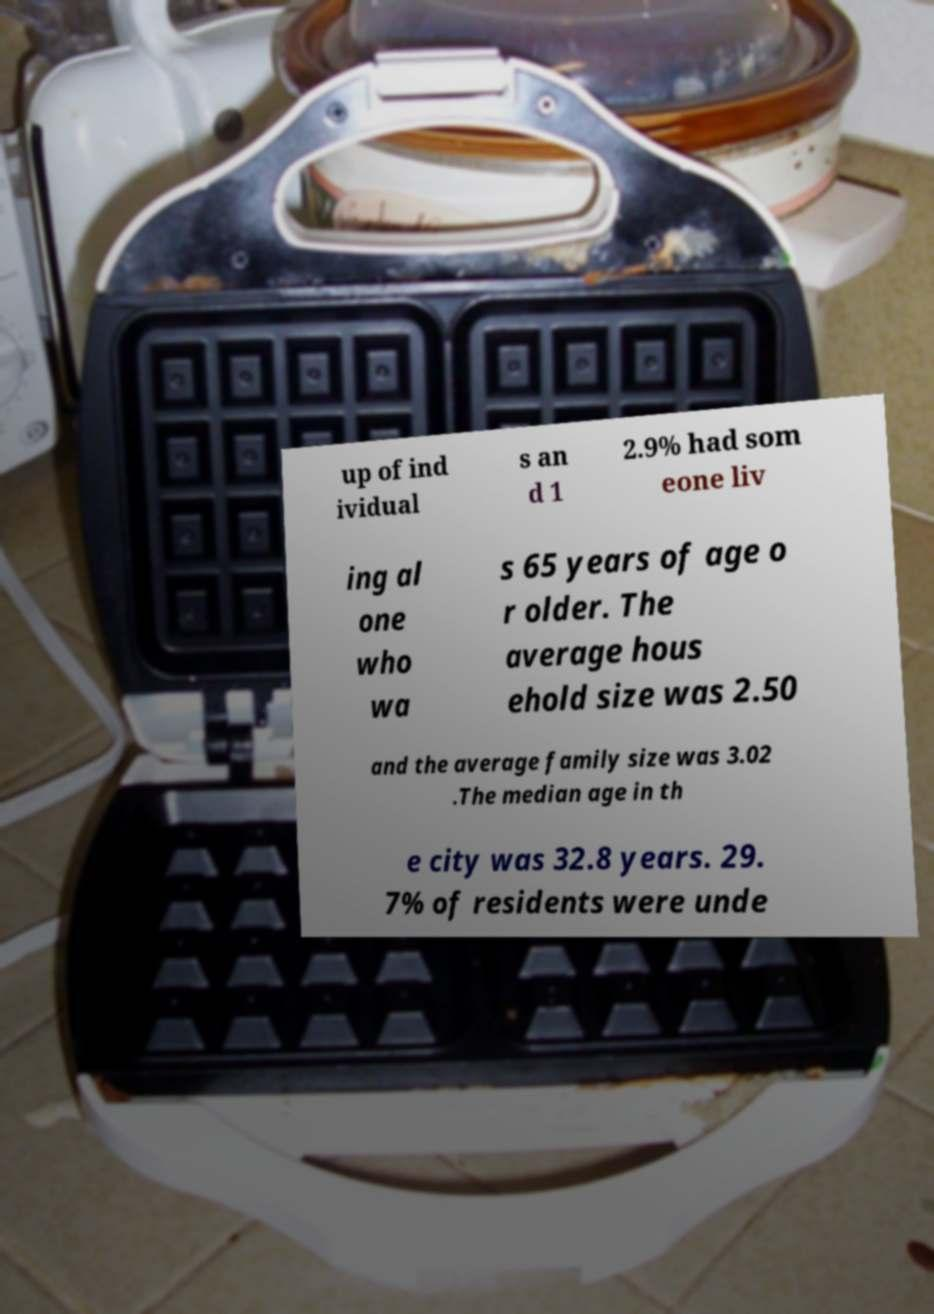Could you assist in decoding the text presented in this image and type it out clearly? up of ind ividual s an d 1 2.9% had som eone liv ing al one who wa s 65 years of age o r older. The average hous ehold size was 2.50 and the average family size was 3.02 .The median age in th e city was 32.8 years. 29. 7% of residents were unde 